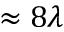<formula> <loc_0><loc_0><loc_500><loc_500>\approx 8 \lambda</formula> 